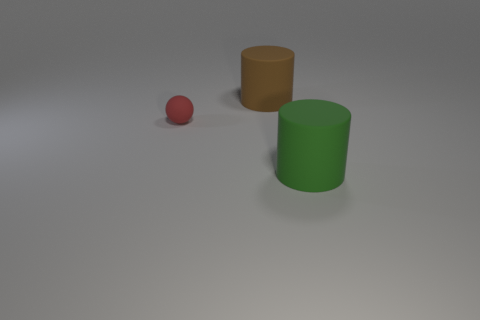How many cylinders are small matte objects or large matte objects?
Provide a succinct answer. 2. Does the green matte thing have the same shape as the thing behind the tiny matte ball?
Keep it short and to the point. Yes. What number of purple spheres have the same size as the green cylinder?
Make the answer very short. 0. Do the tiny red rubber thing that is behind the green cylinder and the large matte thing that is left of the big green thing have the same shape?
Your answer should be very brief. No. What color is the big object that is left of the thing on the right side of the large brown cylinder?
Provide a succinct answer. Brown. What color is the other big rubber thing that is the same shape as the brown thing?
Your response must be concise. Green. There is another object that is the same shape as the brown object; what size is it?
Give a very brief answer. Large. What is the big green cylinder that is in front of the tiny red matte sphere made of?
Offer a very short reply. Rubber. Is the number of tiny red matte things that are right of the tiny rubber object less than the number of small purple cylinders?
Provide a succinct answer. No. What is the shape of the matte object in front of the rubber object that is to the left of the brown cylinder?
Offer a terse response. Cylinder. 